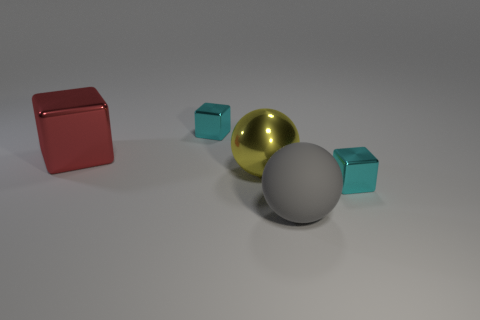Add 2 small metallic cubes. How many objects exist? 7 Subtract all blocks. How many objects are left? 2 Add 1 cyan metallic things. How many cyan metallic things exist? 3 Subtract 0 yellow blocks. How many objects are left? 5 Subtract all yellow rubber blocks. Subtract all big yellow balls. How many objects are left? 4 Add 5 large yellow metal things. How many large yellow metal things are left? 6 